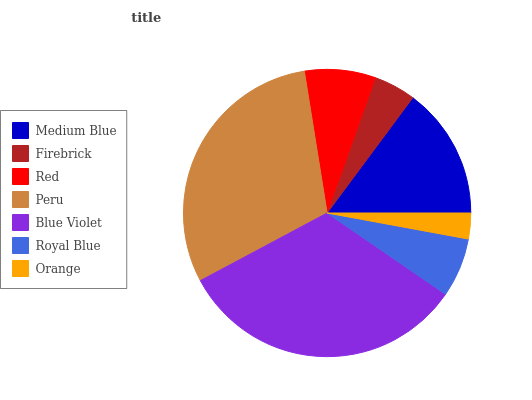Is Orange the minimum?
Answer yes or no. Yes. Is Blue Violet the maximum?
Answer yes or no. Yes. Is Firebrick the minimum?
Answer yes or no. No. Is Firebrick the maximum?
Answer yes or no. No. Is Medium Blue greater than Firebrick?
Answer yes or no. Yes. Is Firebrick less than Medium Blue?
Answer yes or no. Yes. Is Firebrick greater than Medium Blue?
Answer yes or no. No. Is Medium Blue less than Firebrick?
Answer yes or no. No. Is Red the high median?
Answer yes or no. Yes. Is Red the low median?
Answer yes or no. Yes. Is Blue Violet the high median?
Answer yes or no. No. Is Firebrick the low median?
Answer yes or no. No. 